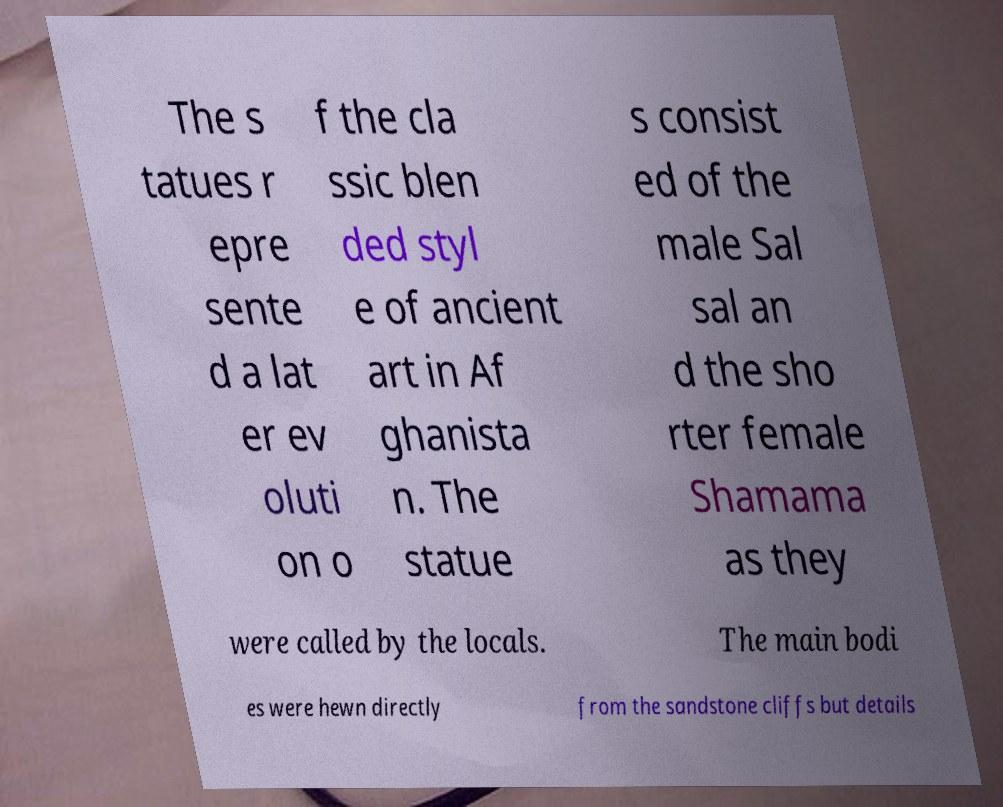Could you extract and type out the text from this image? The s tatues r epre sente d a lat er ev oluti on o f the cla ssic blen ded styl e of ancient art in Af ghanista n. The statue s consist ed of the male Sal sal an d the sho rter female Shamama as they were called by the locals. The main bodi es were hewn directly from the sandstone cliffs but details 